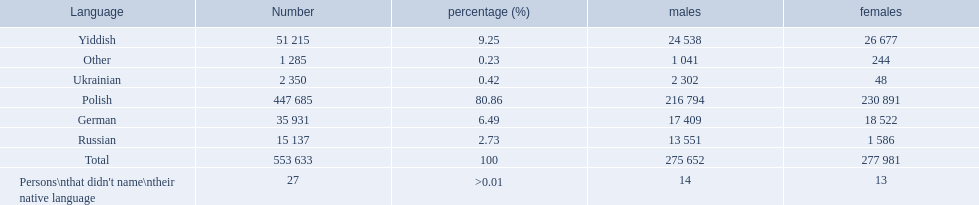What languages are there? Polish, Yiddish, German, Russian, Ukrainian. What numbers speak these languages? 447 685, 51 215, 35 931, 15 137, 2 350. What numbers are not listed as speaking these languages? 1 285, 27. What are the totals of these speakers? 553 633. 